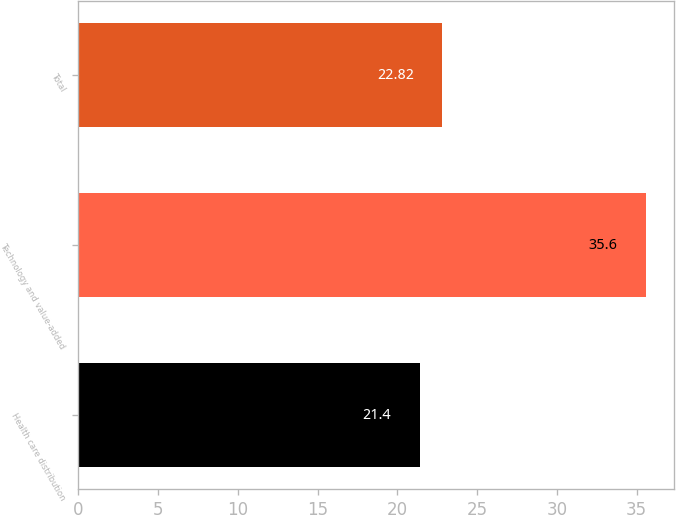Convert chart. <chart><loc_0><loc_0><loc_500><loc_500><bar_chart><fcel>Health care distribution<fcel>Technology and value-added<fcel>Total<nl><fcel>21.4<fcel>35.6<fcel>22.82<nl></chart> 